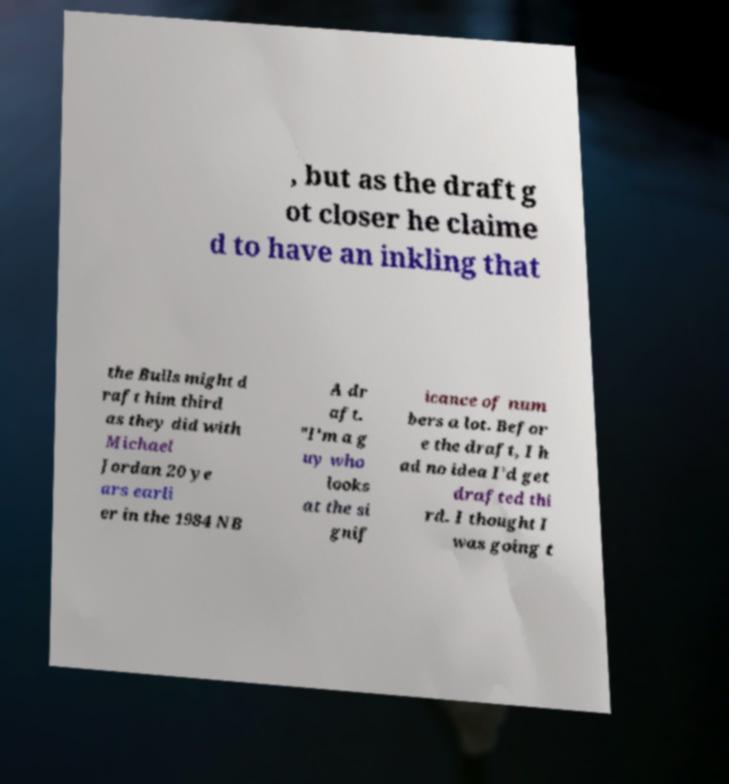Please read and relay the text visible in this image. What does it say? , but as the draft g ot closer he claime d to have an inkling that the Bulls might d raft him third as they did with Michael Jordan 20 ye ars earli er in the 1984 NB A dr aft. "I'm a g uy who looks at the si gnif icance of num bers a lot. Befor e the draft, I h ad no idea I'd get drafted thi rd. I thought I was going t 